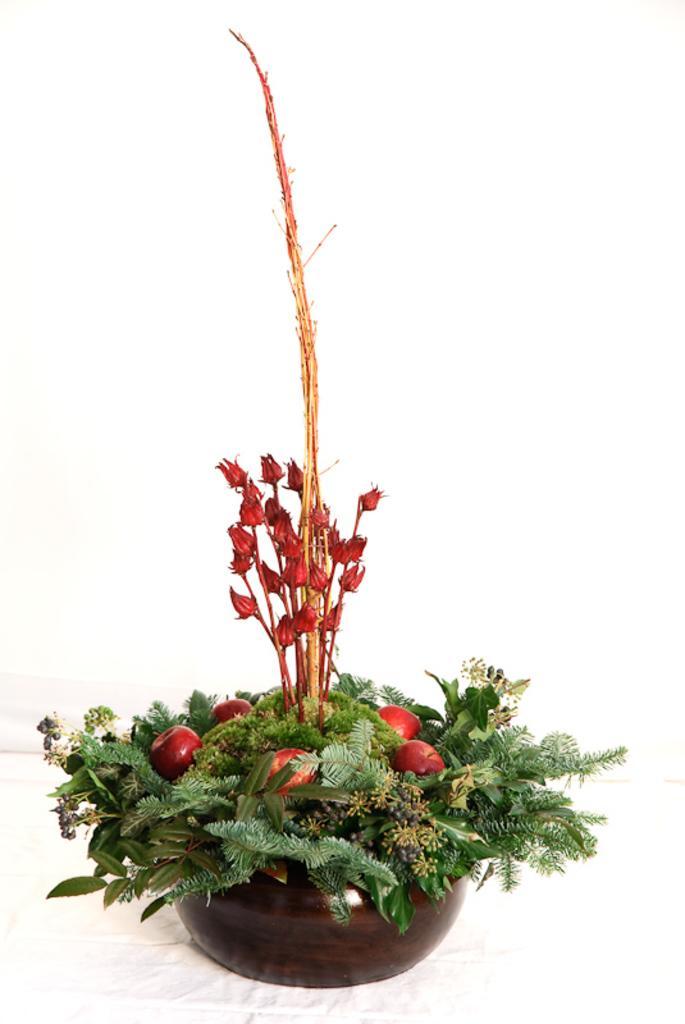How would you summarize this image in a sentence or two? In this image I can see few leaves in green color, fruits in red color and flowers also in red color, in a brown color pot and I can see white color background. 